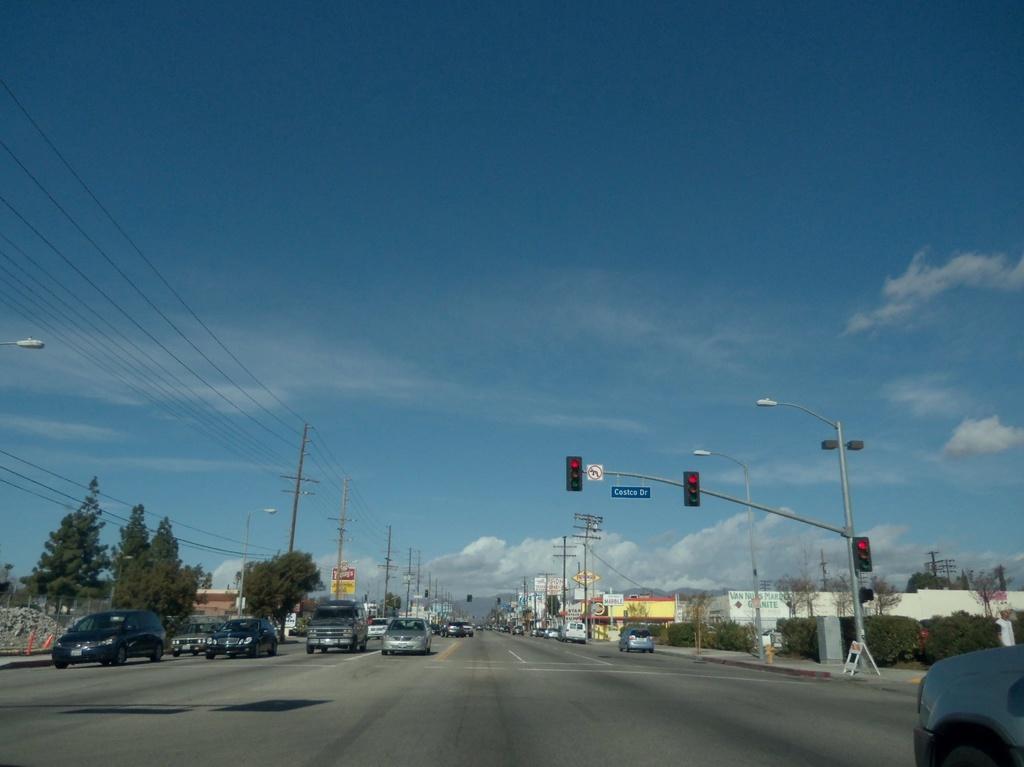Could you give a brief overview of what you see in this image? In this image we can see vehicles on the road, there are wires connected to the electric poles, there are boards with text on them, there are light poles, traffic lights, there are plants, trees, houses, also we can see the sky. 